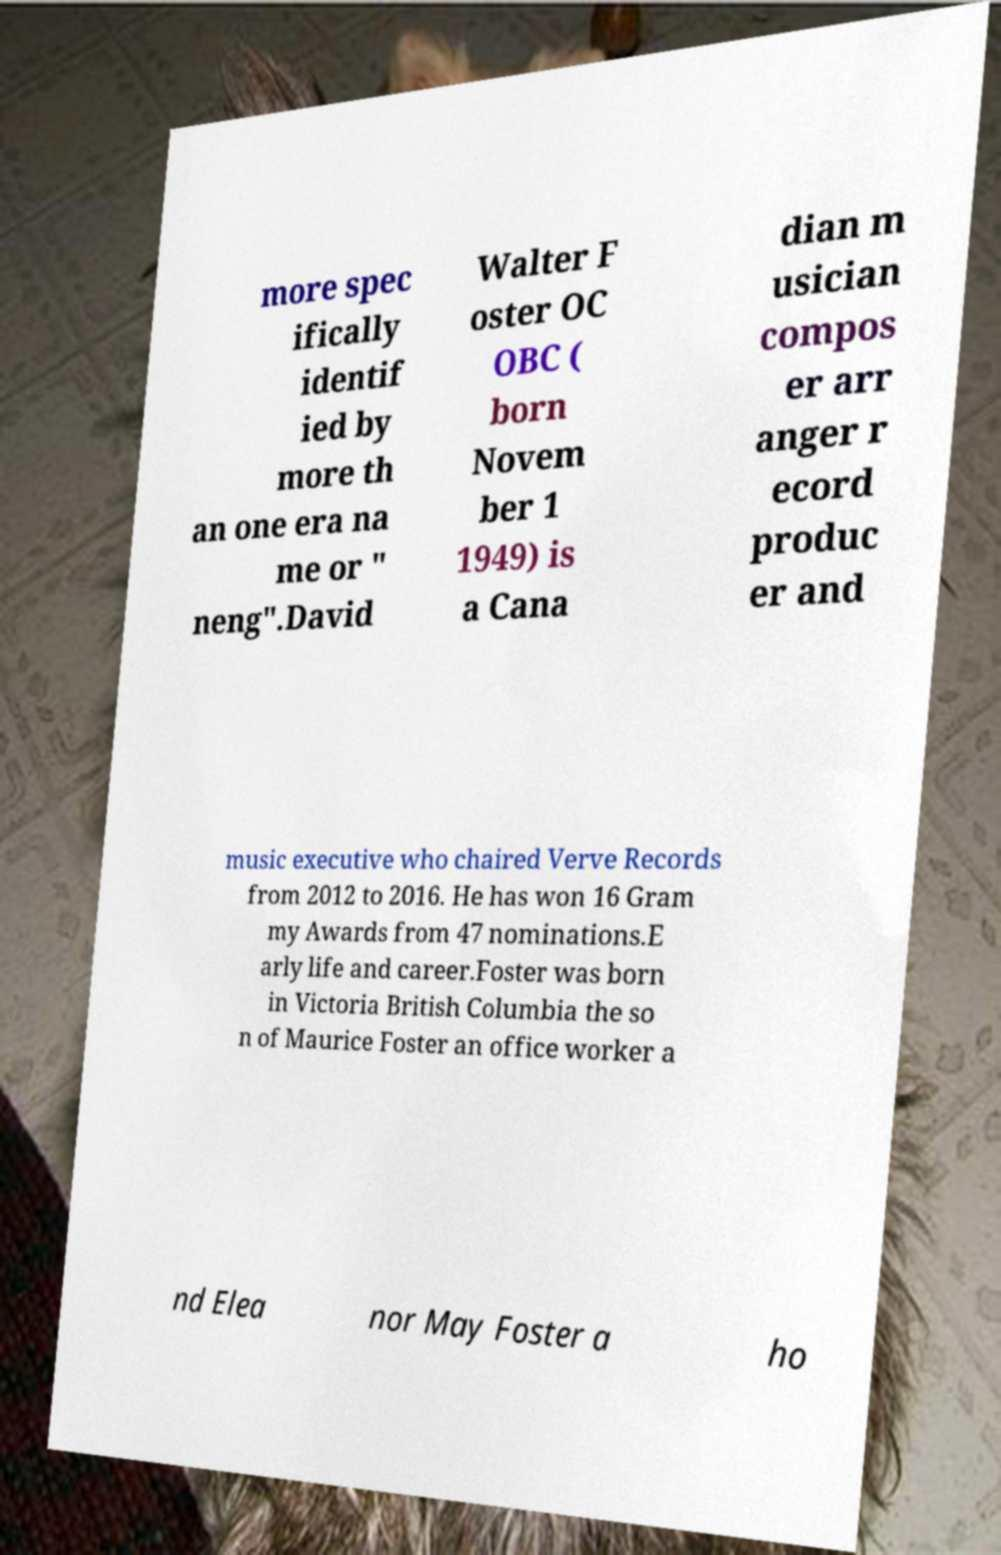Please read and relay the text visible in this image. What does it say? more spec ifically identif ied by more th an one era na me or " neng".David Walter F oster OC OBC ( born Novem ber 1 1949) is a Cana dian m usician compos er arr anger r ecord produc er and music executive who chaired Verve Records from 2012 to 2016. He has won 16 Gram my Awards from 47 nominations.E arly life and career.Foster was born in Victoria British Columbia the so n of Maurice Foster an office worker a nd Elea nor May Foster a ho 